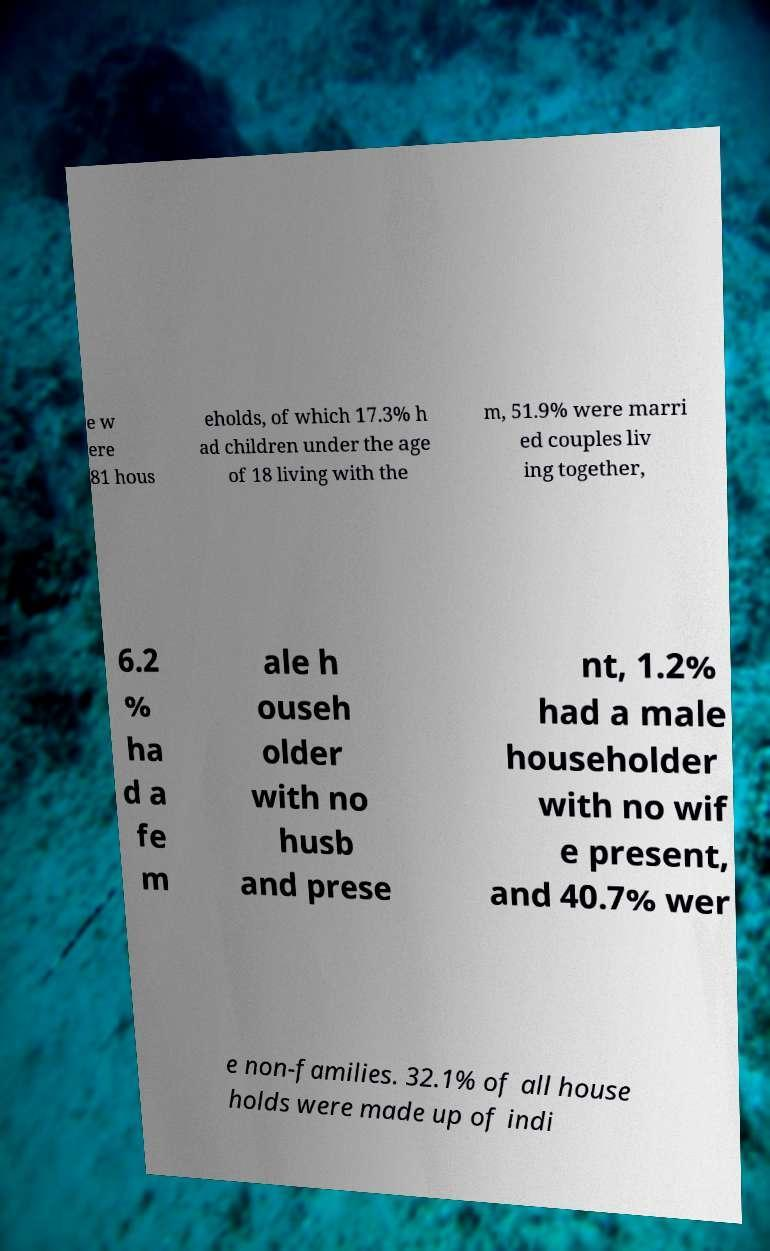What messages or text are displayed in this image? I need them in a readable, typed format. e w ere 81 hous eholds, of which 17.3% h ad children under the age of 18 living with the m, 51.9% were marri ed couples liv ing together, 6.2 % ha d a fe m ale h ouseh older with no husb and prese nt, 1.2% had a male householder with no wif e present, and 40.7% wer e non-families. 32.1% of all house holds were made up of indi 